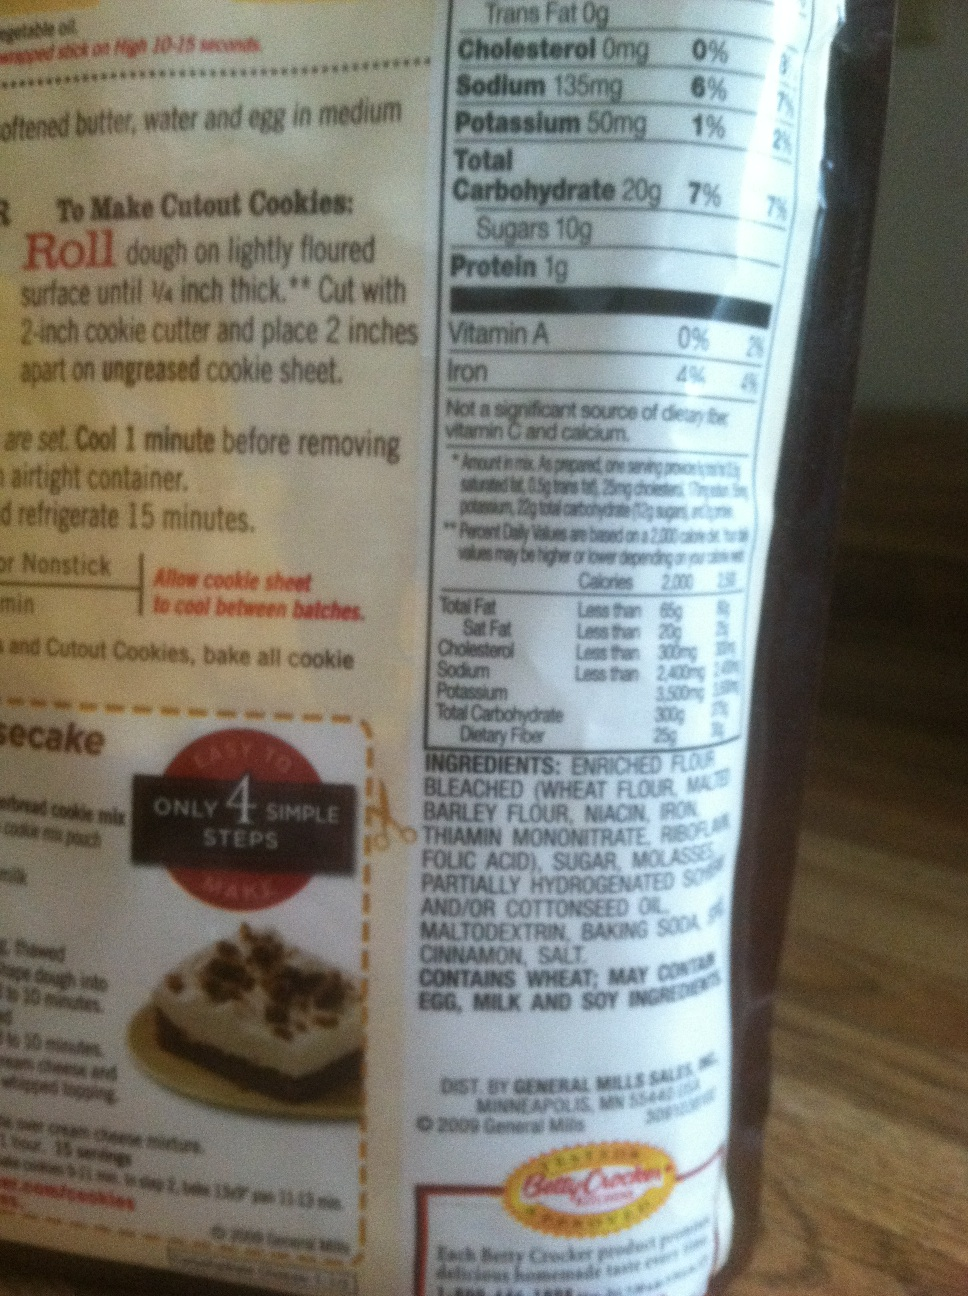If you were to create a marketing campaign for this product, what angle would you take? A great marketing angle would be to highlight the ease and fun of baking with family or friends. The campaign could be titled 'Bake Memories' and focus on the joy of creating delicious and beautiful treats together. Featuring real families or friends baking and enjoying the cookies would make it relatable and appealing. Offering tips for creative cookie designs and sharing user-generated content would engage the community further. 